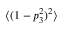<formula> <loc_0><loc_0><loc_500><loc_500>\langle ( 1 - p _ { 3 } ^ { 2 } ) ^ { 2 } \rangle</formula> 